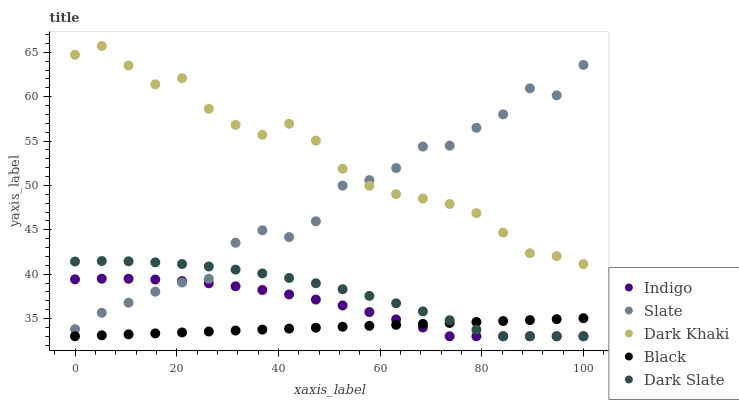Does Black have the minimum area under the curve?
Answer yes or no. Yes. Does Dark Khaki have the maximum area under the curve?
Answer yes or no. Yes. Does Slate have the minimum area under the curve?
Answer yes or no. No. Does Slate have the maximum area under the curve?
Answer yes or no. No. Is Black the smoothest?
Answer yes or no. Yes. Is Slate the roughest?
Answer yes or no. Yes. Is Slate the smoothest?
Answer yes or no. No. Is Black the roughest?
Answer yes or no. No. Does Black have the lowest value?
Answer yes or no. Yes. Does Slate have the lowest value?
Answer yes or no. No. Does Dark Khaki have the highest value?
Answer yes or no. Yes. Does Slate have the highest value?
Answer yes or no. No. Is Black less than Dark Khaki?
Answer yes or no. Yes. Is Dark Khaki greater than Black?
Answer yes or no. Yes. Does Slate intersect Dark Slate?
Answer yes or no. Yes. Is Slate less than Dark Slate?
Answer yes or no. No. Is Slate greater than Dark Slate?
Answer yes or no. No. Does Black intersect Dark Khaki?
Answer yes or no. No. 